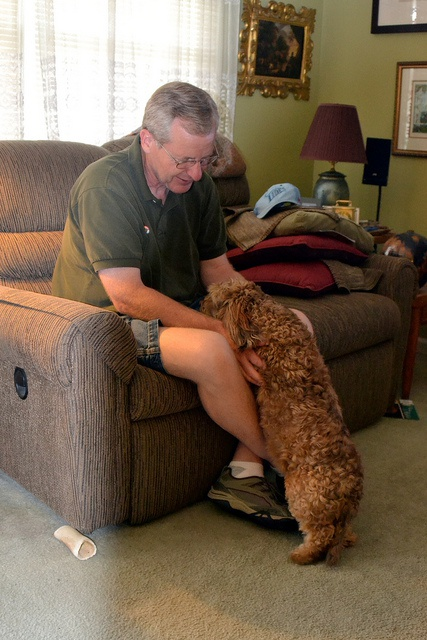Describe the objects in this image and their specific colors. I can see couch in ivory, black, gray, and maroon tones, people in ivory, black, gray, and brown tones, and dog in ivory, maroon, black, and brown tones in this image. 